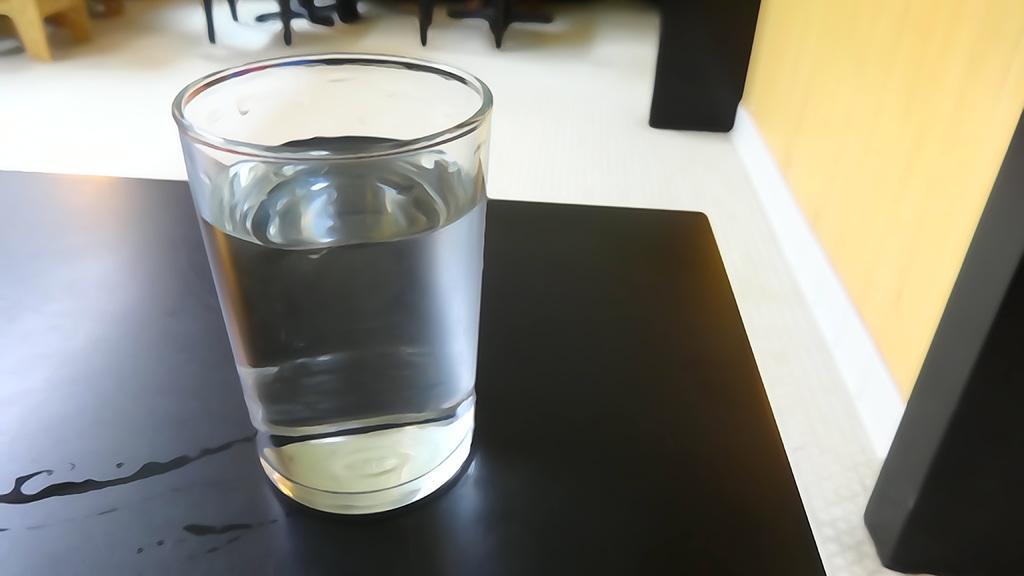In one or two sentences, can you explain what this image depicts? In this picture there is a table towards the left, on the table there is a glass full of water. Towards the right there is a wall and two pillars. 